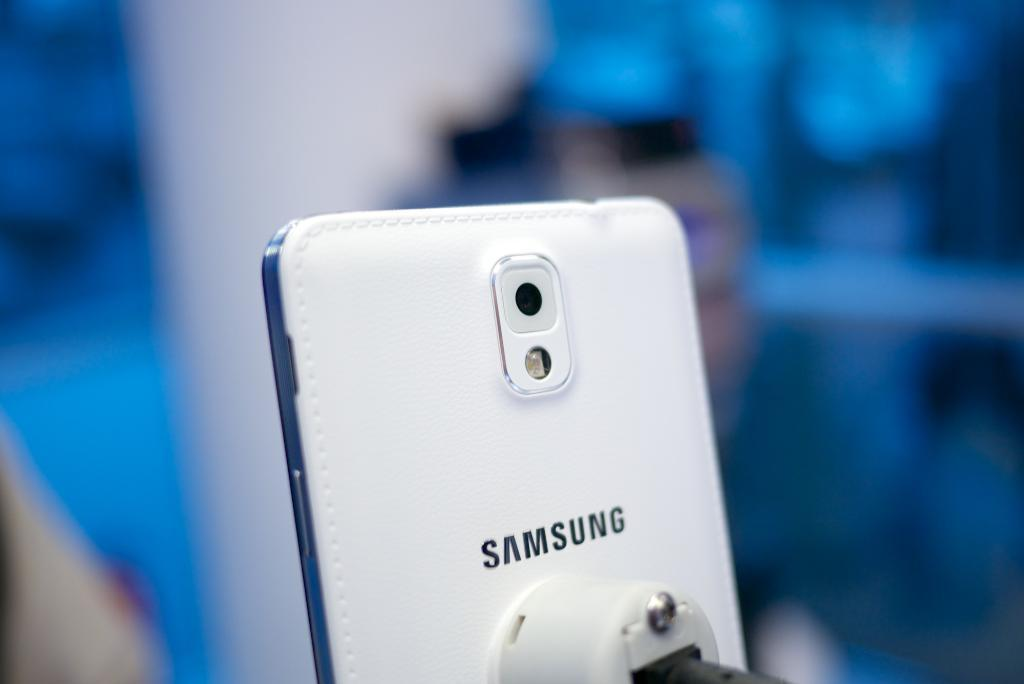<image>
Share a concise interpretation of the image provided. the back of a white Samsung phone on display somewhere 